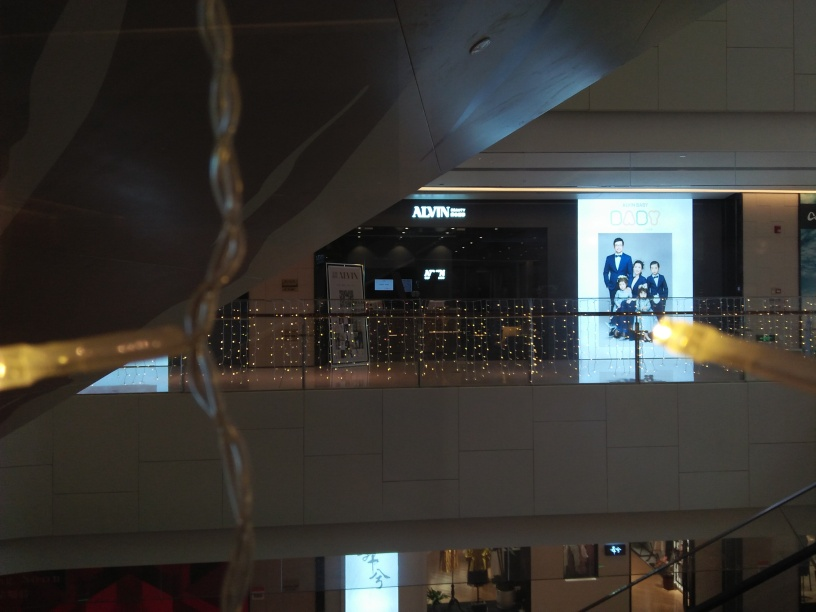What does the ambiance of the place in the picture suggest? The ambiance created by the twinkling lights and modern architecture suggests a contemporary and upscale setting, possibly a shopping center or mall. It reflects a space designed for leisure and commercial activities, inviting visitors to browse through high-end stores or perhaps enjoy an evening out. 